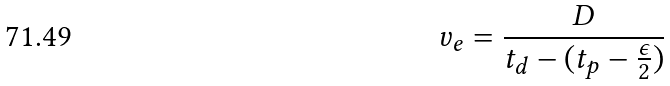<formula> <loc_0><loc_0><loc_500><loc_500>v _ { e } = \frac { D } { t _ { d } - ( t _ { p } - \frac { \epsilon } { 2 } ) }</formula> 